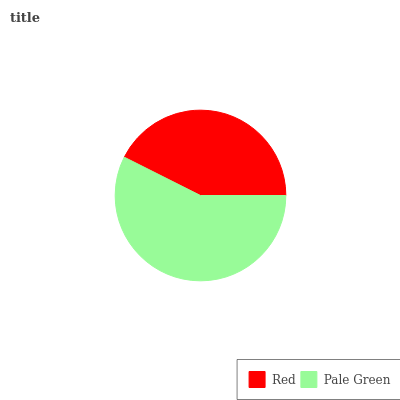Is Red the minimum?
Answer yes or no. Yes. Is Pale Green the maximum?
Answer yes or no. Yes. Is Pale Green the minimum?
Answer yes or no. No. Is Pale Green greater than Red?
Answer yes or no. Yes. Is Red less than Pale Green?
Answer yes or no. Yes. Is Red greater than Pale Green?
Answer yes or no. No. Is Pale Green less than Red?
Answer yes or no. No. Is Pale Green the high median?
Answer yes or no. Yes. Is Red the low median?
Answer yes or no. Yes. Is Red the high median?
Answer yes or no. No. Is Pale Green the low median?
Answer yes or no. No. 